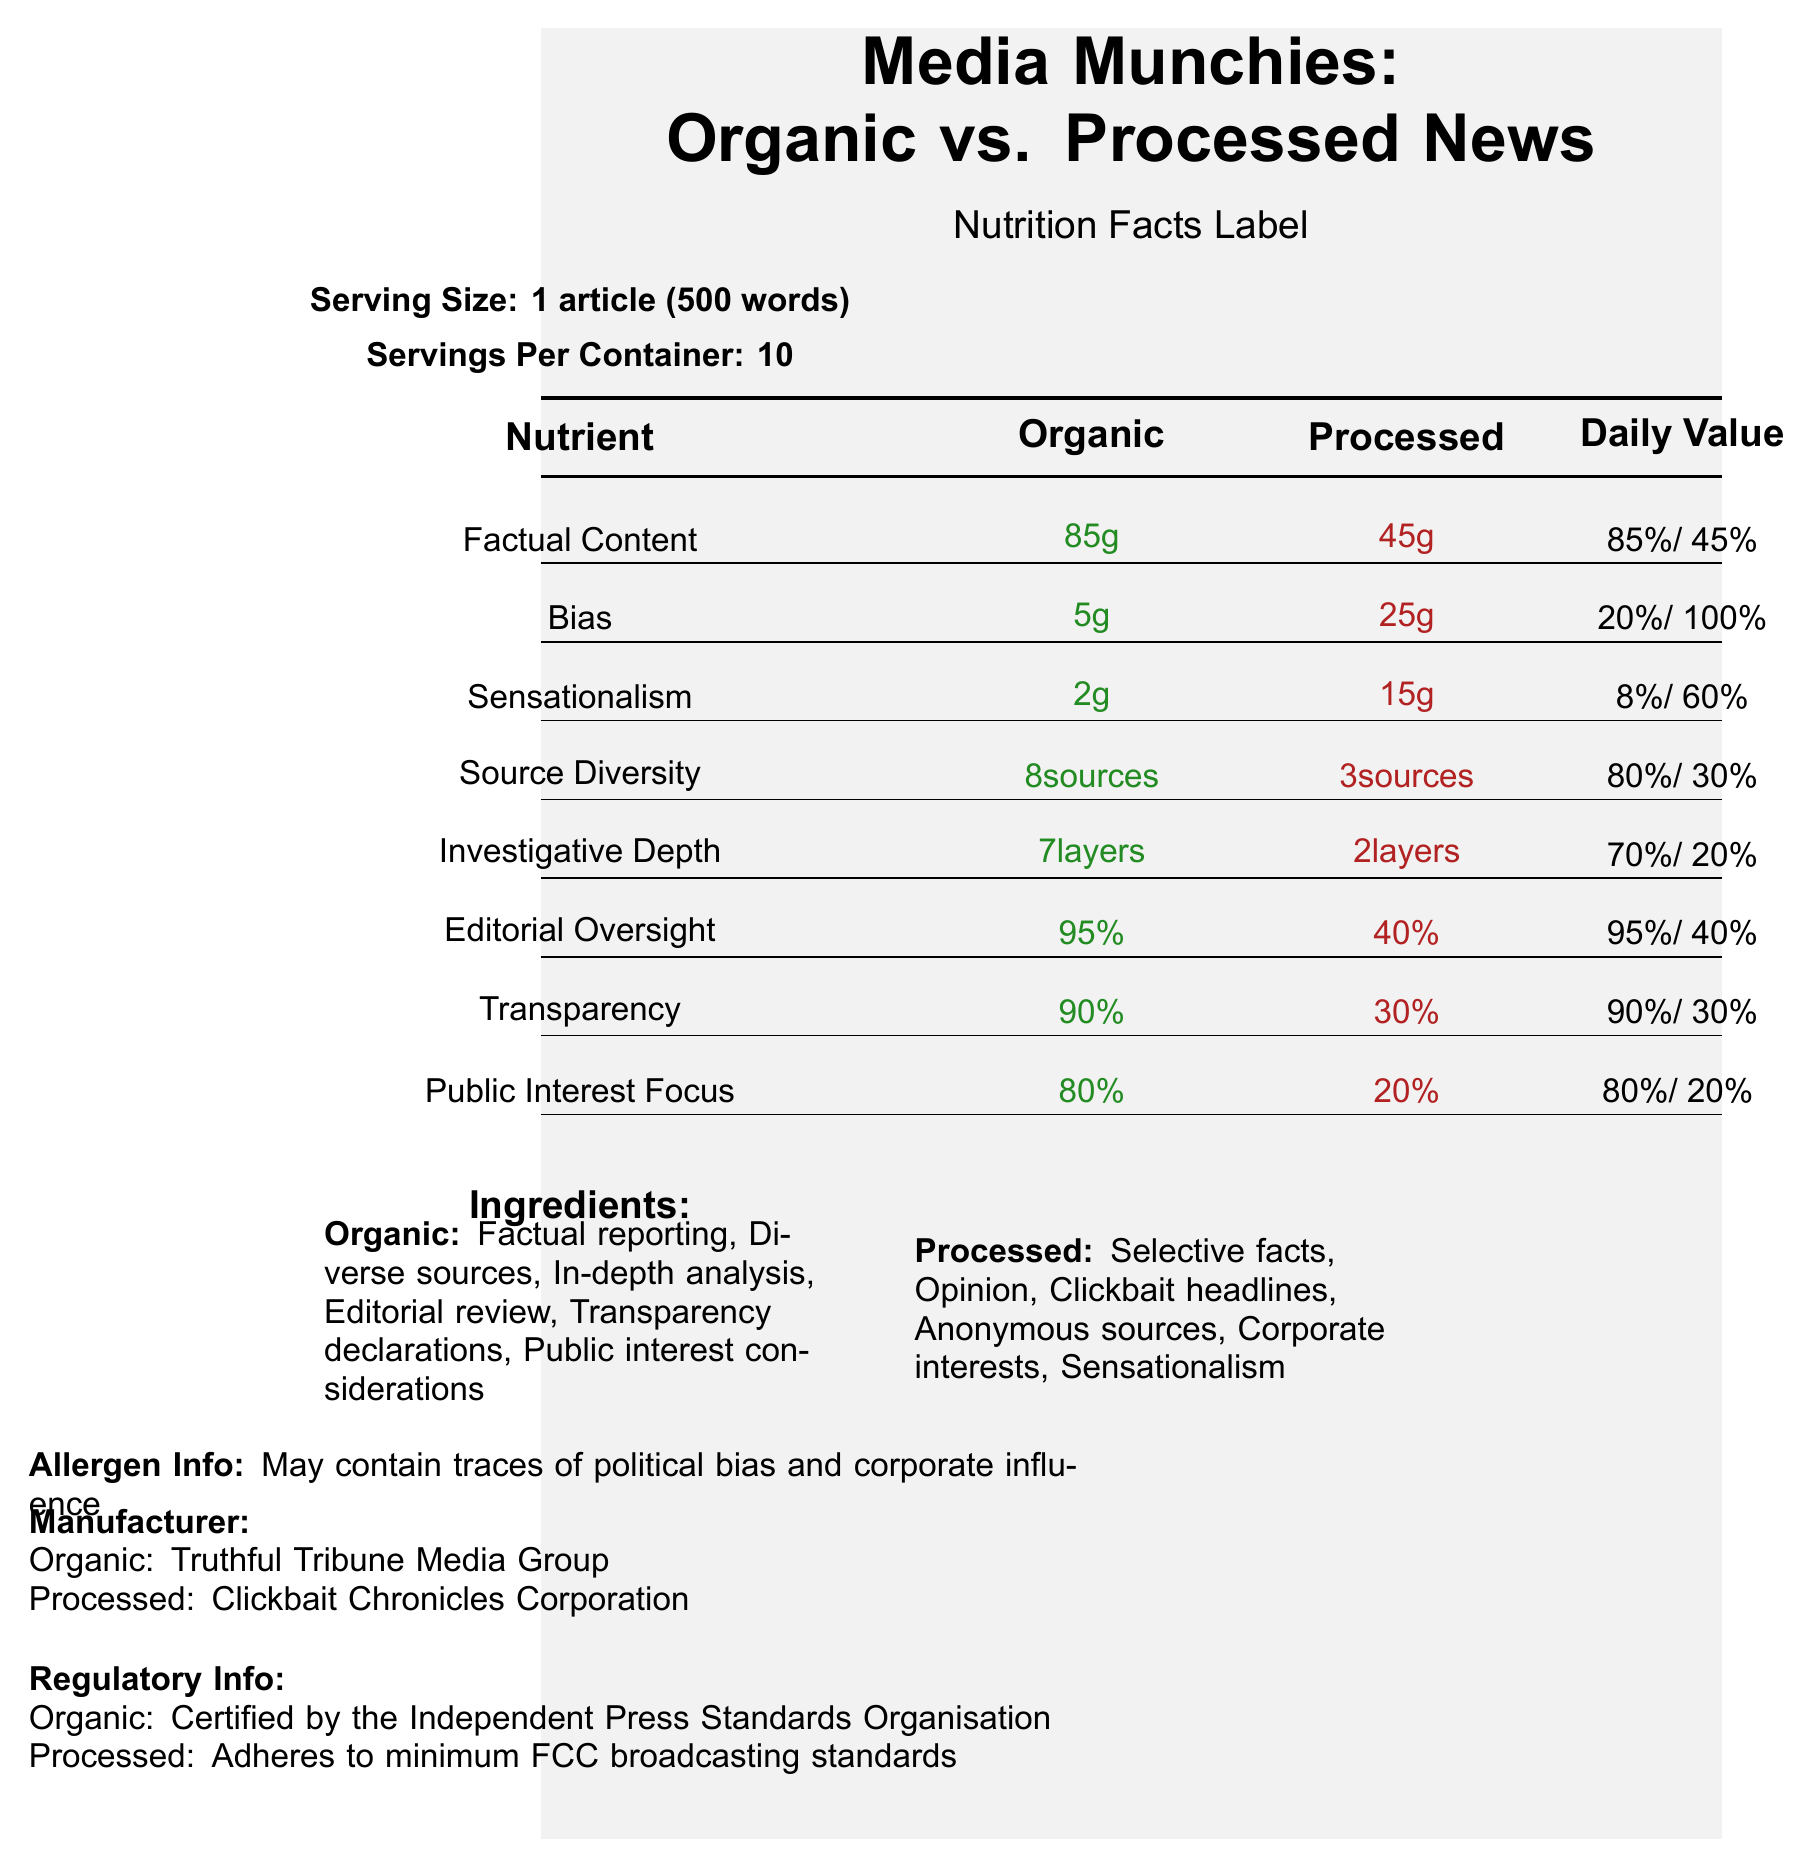what is the product name presented in the document? The product name is clearly stated at the top of the document.
Answer: Media Munchies: Organic vs. Processed News what is the serving size for this product? The serving size is mentioned below the title in the section labeled 'Serving Size.'
Answer: 1 article (500 words) how many grams of factual content does the organic version contain? The factual content for organic is listed as 85 grams in the 'Nutrition Facts' table.
Answer: 85 grams how does the level of bias compare between organic and processed news? The bias levels are shown in the 'Nutrition Facts' table, with organic at 5 grams and processed at 25 grams.
Answer: Organic has 5 grams of bias, processed has 25 grams of bias who is the manufacturer of the organic version? The manufacturer's information is given near the bottom of the document.
Answer: Truthful Tribune Media Group how is the investigative depth measured in organic news media? A. grams B. sources C. layers D. percent The 'Nutrition Facts' table lists investigative depth for organic as 7 layers.
Answer: C. layers what daily value percentage of editorial oversight does the organic version have? A. 70% B. 80% C. 90% D. 95% The daily value percentage of editorial oversight for organic is 95%, as shown in the 'Nutrition Facts' table.
Answer: D. 95% is the organic news media certified by any organization? The organic news media is certified by the Independent Press Standards Organisation, as indicated in the 'Regulatory Info' section.
Answer: Yes does processed news media adhere to the Independent Press Standards Organisation? The processed news media adheres to minimum FCC broadcasting standards, not the Independent Press Standards Organisation.
Answer: No what allergens may both types of media contain? This information is found in the 'Allergen Info' section.
Answer: Traces of political bias and corporate influence what ingredients are common in processed news media? The 'Ingredients' section for processed news media lists these items.
Answer: Selective facts, Opinion, Clickbait headlines, Anonymous sources, Corporate interests, Sensationalism which nutrient has the largest disparity in daily value percentage between organic and processed news? The daily value percentage for bias is 20% for organic and 100% for processed, showing the largest disparity.
Answer: Bias describe the main idea of the document. The document offers a detailed comparison between organic and processed news media, focusing on various nutritional and qualitative metrics to illustrate the differences in news quality.
Answer: The document presents a comparative analysis of nutritional facts between organic and processed news media articles, highlighting differences in factors such as factual content, bias, sensationalism, source diversity, investigative depth, editorial oversight, transparency, and public interest focus. It includes additional information like ingredients, allergens, manufacturer details, and regulatory info. what is the transparency score on a scale of 1-10 for processed news media according to the lawmaker notes? The lawmaker notes section lists the transparency score for processed news media as 3 on a scale of 1-10.
Answer: 3 what type of verification is required for organic news media? The lawmaker notes specify that organic news media undergo stringent third-party verification.
Answer: Stringent third-party verification how many servings per container are there? This information is provided near the top under 'Serving Per Container.'
Answer: 10 what percentage of public trust does organic news media have? The public trust index for organic news media is 85%, according to the lawmaker notes.
Answer: 85% is there information about the international compliance of these media types? The document does not mention anything about international compliance standards for these media types.
Answer: Not enough information what is the daily value percentage of factual content in processed news media? The 'Nutrition Facts' table lists the daily value percentage of factual content for processed news media as 45%.
Answer: 45% 